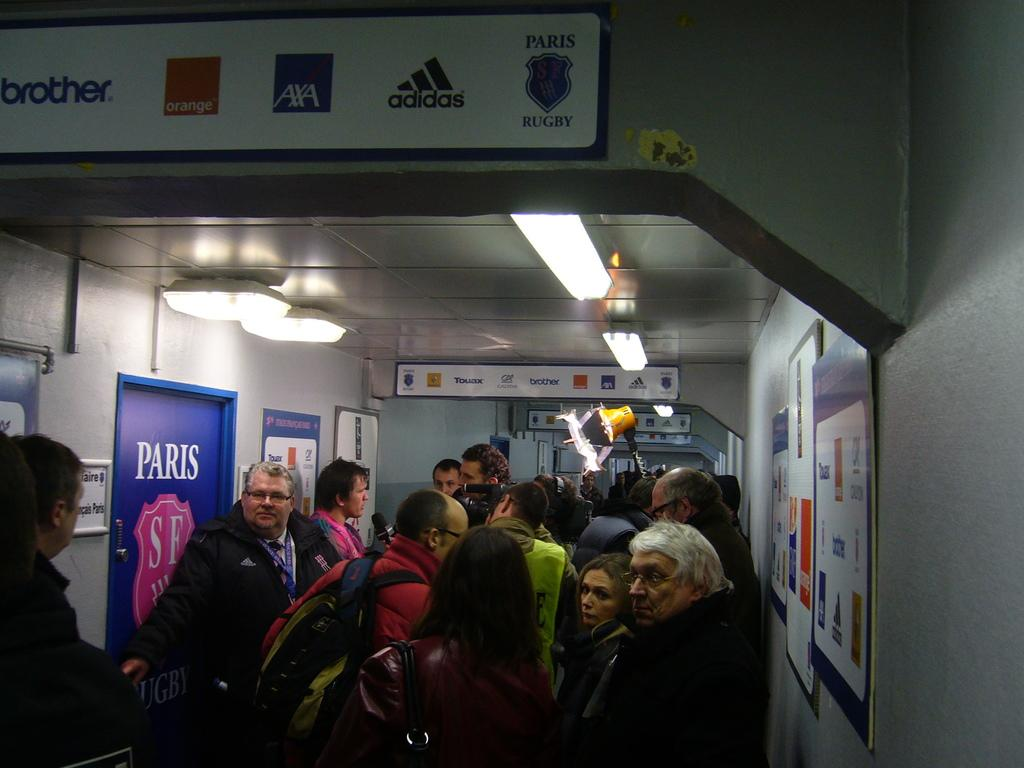How many people are in the image? There are persons in the image, but the exact number is not specified. Where are the persons located in the image? The persons are at the bottom of the image. What can be seen in the middle of the image? There is light in the middle of the image. What is on the left side of the image? There is a door on the left side of the image. What type of orange is being used to give approval in the image? There is no orange present in the image, nor is there any indication of approval being given. 